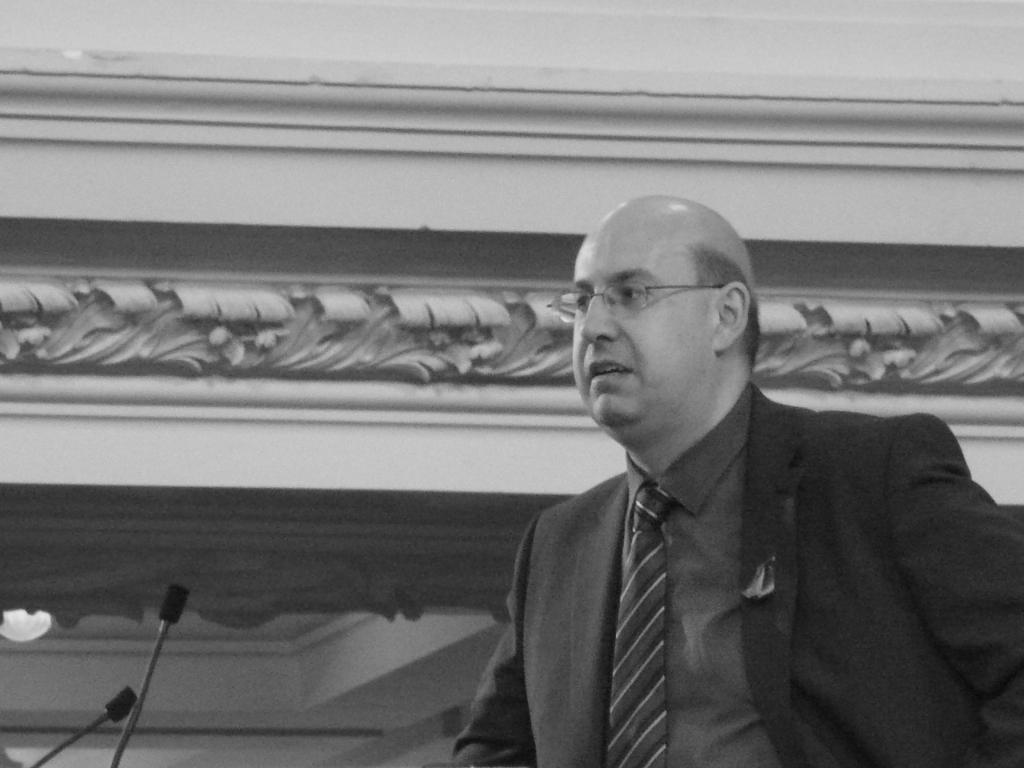Who or what is on the right side of the image? There is a person on the right side of the image. What objects are in front of the person? There are two microphones in front of the person. What is behind the person? There is a wall behind the person. Can you describe an object in the bottom left of the image? There is a lamp on the bottom left of the image. How does the person twist their stomach in the image? The person does not twist their stomach in the image; there is no indication of any such action. 